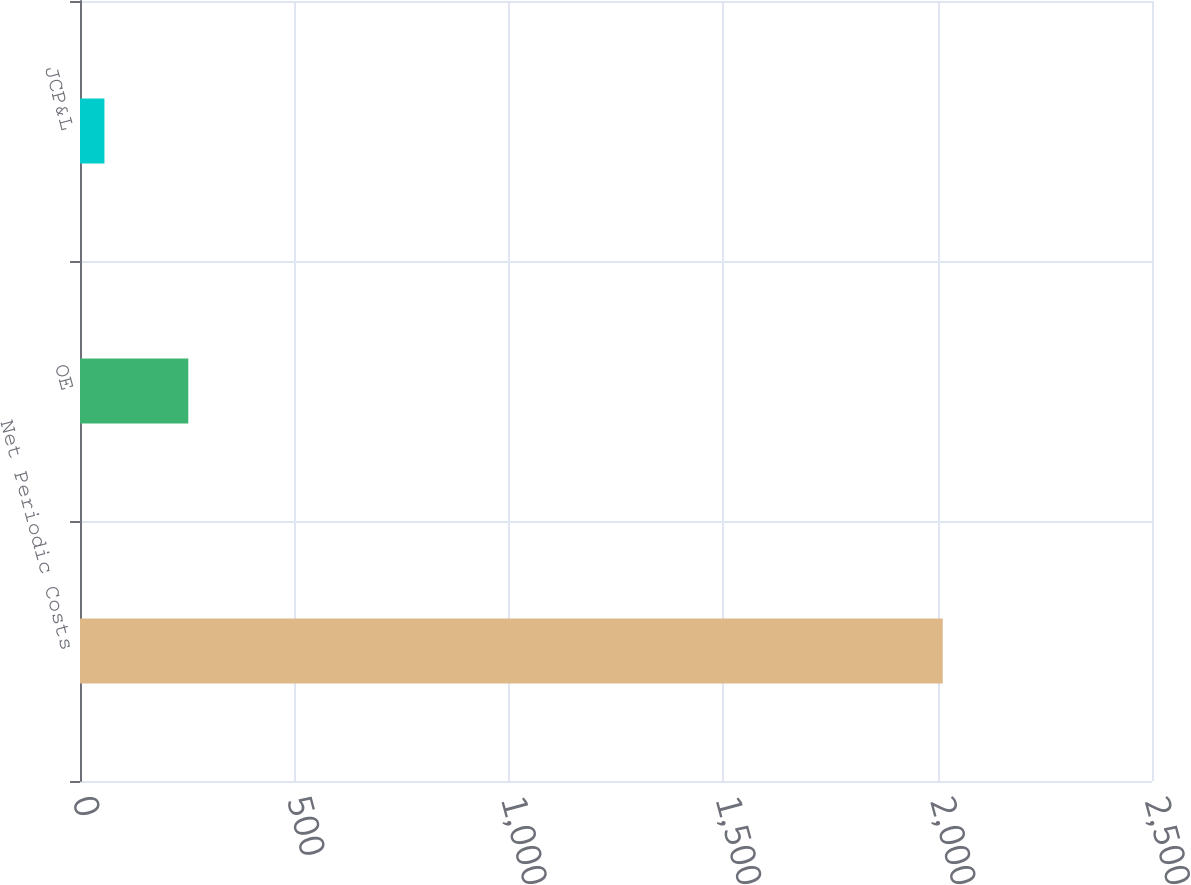<chart> <loc_0><loc_0><loc_500><loc_500><bar_chart><fcel>Net Periodic Costs<fcel>OE<fcel>JCP&L<nl><fcel>2012<fcel>252.5<fcel>57<nl></chart> 